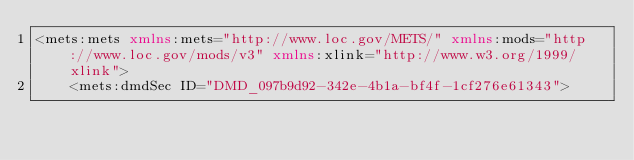<code> <loc_0><loc_0><loc_500><loc_500><_XML_><mets:mets xmlns:mets="http://www.loc.gov/METS/" xmlns:mods="http://www.loc.gov/mods/v3" xmlns:xlink="http://www.w3.org/1999/xlink">
    <mets:dmdSec ID="DMD_097b9d92-342e-4b1a-bf4f-1cf276e61343"></code> 